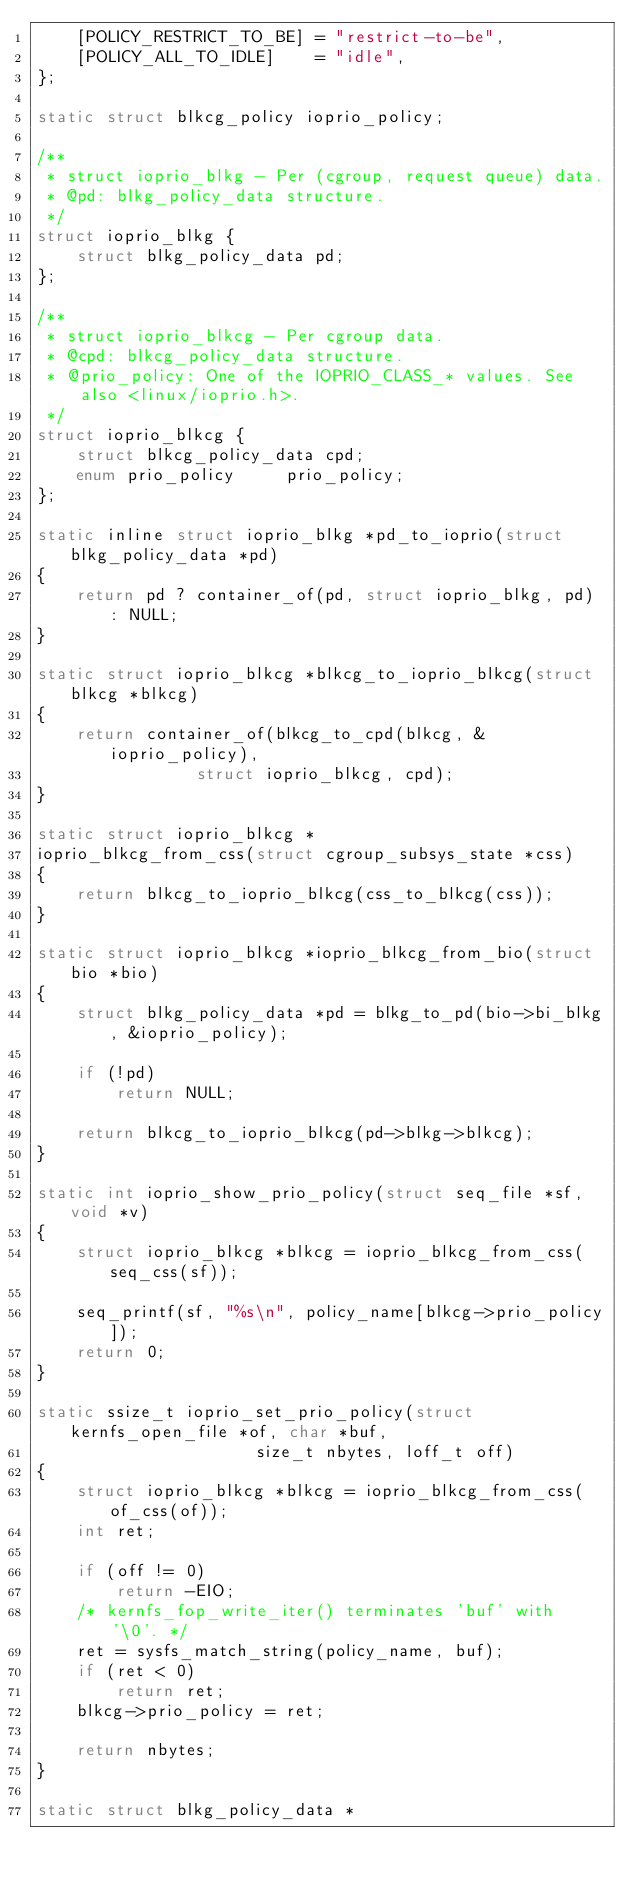<code> <loc_0><loc_0><loc_500><loc_500><_C_>	[POLICY_RESTRICT_TO_BE]	= "restrict-to-be",
	[POLICY_ALL_TO_IDLE]	= "idle",
};

static struct blkcg_policy ioprio_policy;

/**
 * struct ioprio_blkg - Per (cgroup, request queue) data.
 * @pd: blkg_policy_data structure.
 */
struct ioprio_blkg {
	struct blkg_policy_data pd;
};

/**
 * struct ioprio_blkcg - Per cgroup data.
 * @cpd: blkcg_policy_data structure.
 * @prio_policy: One of the IOPRIO_CLASS_* values. See also <linux/ioprio.h>.
 */
struct ioprio_blkcg {
	struct blkcg_policy_data cpd;
	enum prio_policy	 prio_policy;
};

static inline struct ioprio_blkg *pd_to_ioprio(struct blkg_policy_data *pd)
{
	return pd ? container_of(pd, struct ioprio_blkg, pd) : NULL;
}

static struct ioprio_blkcg *blkcg_to_ioprio_blkcg(struct blkcg *blkcg)
{
	return container_of(blkcg_to_cpd(blkcg, &ioprio_policy),
			    struct ioprio_blkcg, cpd);
}

static struct ioprio_blkcg *
ioprio_blkcg_from_css(struct cgroup_subsys_state *css)
{
	return blkcg_to_ioprio_blkcg(css_to_blkcg(css));
}

static struct ioprio_blkcg *ioprio_blkcg_from_bio(struct bio *bio)
{
	struct blkg_policy_data *pd = blkg_to_pd(bio->bi_blkg, &ioprio_policy);

	if (!pd)
		return NULL;

	return blkcg_to_ioprio_blkcg(pd->blkg->blkcg);
}

static int ioprio_show_prio_policy(struct seq_file *sf, void *v)
{
	struct ioprio_blkcg *blkcg = ioprio_blkcg_from_css(seq_css(sf));

	seq_printf(sf, "%s\n", policy_name[blkcg->prio_policy]);
	return 0;
}

static ssize_t ioprio_set_prio_policy(struct kernfs_open_file *of, char *buf,
				      size_t nbytes, loff_t off)
{
	struct ioprio_blkcg *blkcg = ioprio_blkcg_from_css(of_css(of));
	int ret;

	if (off != 0)
		return -EIO;
	/* kernfs_fop_write_iter() terminates 'buf' with '\0'. */
	ret = sysfs_match_string(policy_name, buf);
	if (ret < 0)
		return ret;
	blkcg->prio_policy = ret;

	return nbytes;
}

static struct blkg_policy_data *</code> 